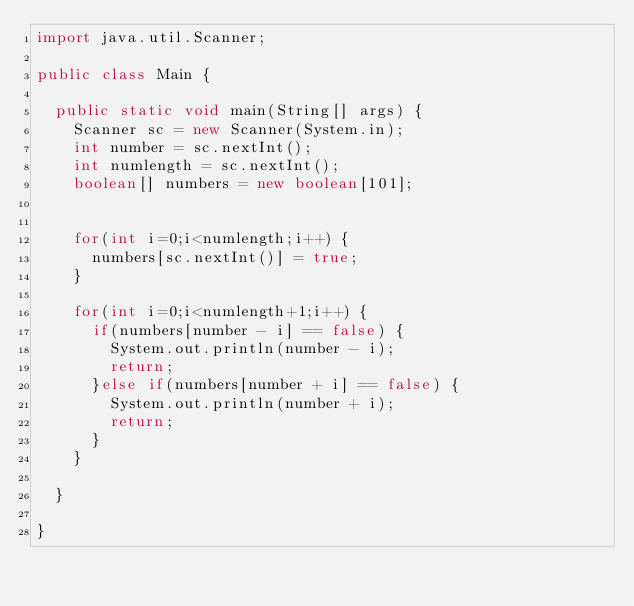<code> <loc_0><loc_0><loc_500><loc_500><_Java_>import java.util.Scanner;

public class Main {

	public static void main(String[] args) {
		Scanner sc = new Scanner(System.in);
		int number = sc.nextInt();
		int numlength = sc.nextInt();
		boolean[] numbers = new boolean[101];
		
		
		for(int i=0;i<numlength;i++) {
			numbers[sc.nextInt()] = true; 
		}
		
		for(int i=0;i<numlength+1;i++) {
			if(numbers[number - i] == false) {
				System.out.println(number - i);
				return;
			}else if(numbers[number + i] == false) {
				System.out.println(number + i);
				return;
			}
		}

	}

}
</code> 